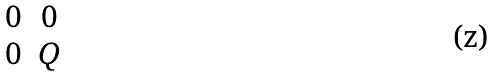<formula> <loc_0><loc_0><loc_500><loc_500>\begin{matrix} 0 & 0 \\ 0 & Q \end{matrix}</formula> 